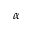Convert formula to latex. <formula><loc_0><loc_0><loc_500><loc_500>\alpha</formula> 